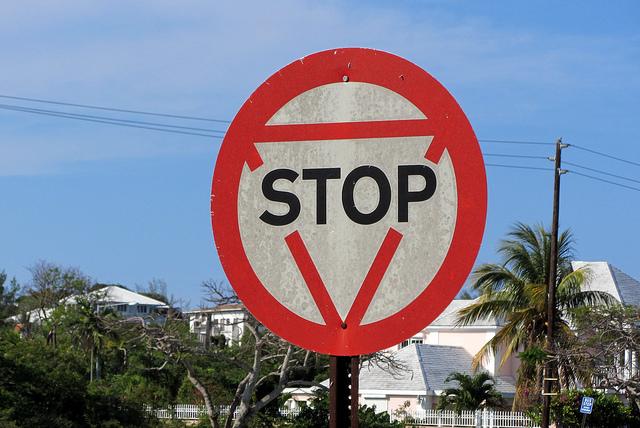What shape is on the inside of the sign?
Be succinct. Triangle. Is this an American stop sign?
Short answer required. No. Would most people consider this area a nice place to live?
Keep it brief. Yes. 